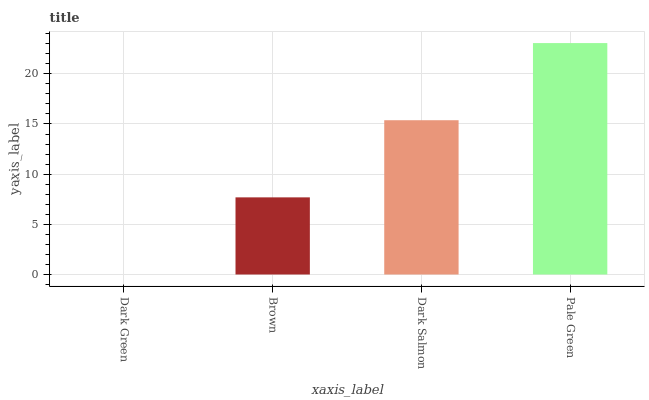Is Dark Green the minimum?
Answer yes or no. Yes. Is Pale Green the maximum?
Answer yes or no. Yes. Is Brown the minimum?
Answer yes or no. No. Is Brown the maximum?
Answer yes or no. No. Is Brown greater than Dark Green?
Answer yes or no. Yes. Is Dark Green less than Brown?
Answer yes or no. Yes. Is Dark Green greater than Brown?
Answer yes or no. No. Is Brown less than Dark Green?
Answer yes or no. No. Is Dark Salmon the high median?
Answer yes or no. Yes. Is Brown the low median?
Answer yes or no. Yes. Is Brown the high median?
Answer yes or no. No. Is Dark Salmon the low median?
Answer yes or no. No. 